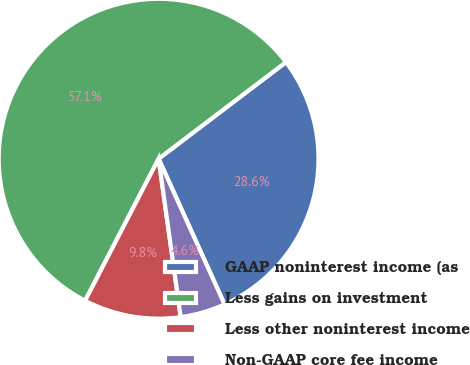Convert chart to OTSL. <chart><loc_0><loc_0><loc_500><loc_500><pie_chart><fcel>GAAP noninterest income (as<fcel>Less gains on investment<fcel>Less other noninterest income<fcel>Non-GAAP core fee income<nl><fcel>28.56%<fcel>57.07%<fcel>9.81%<fcel>4.56%<nl></chart> 